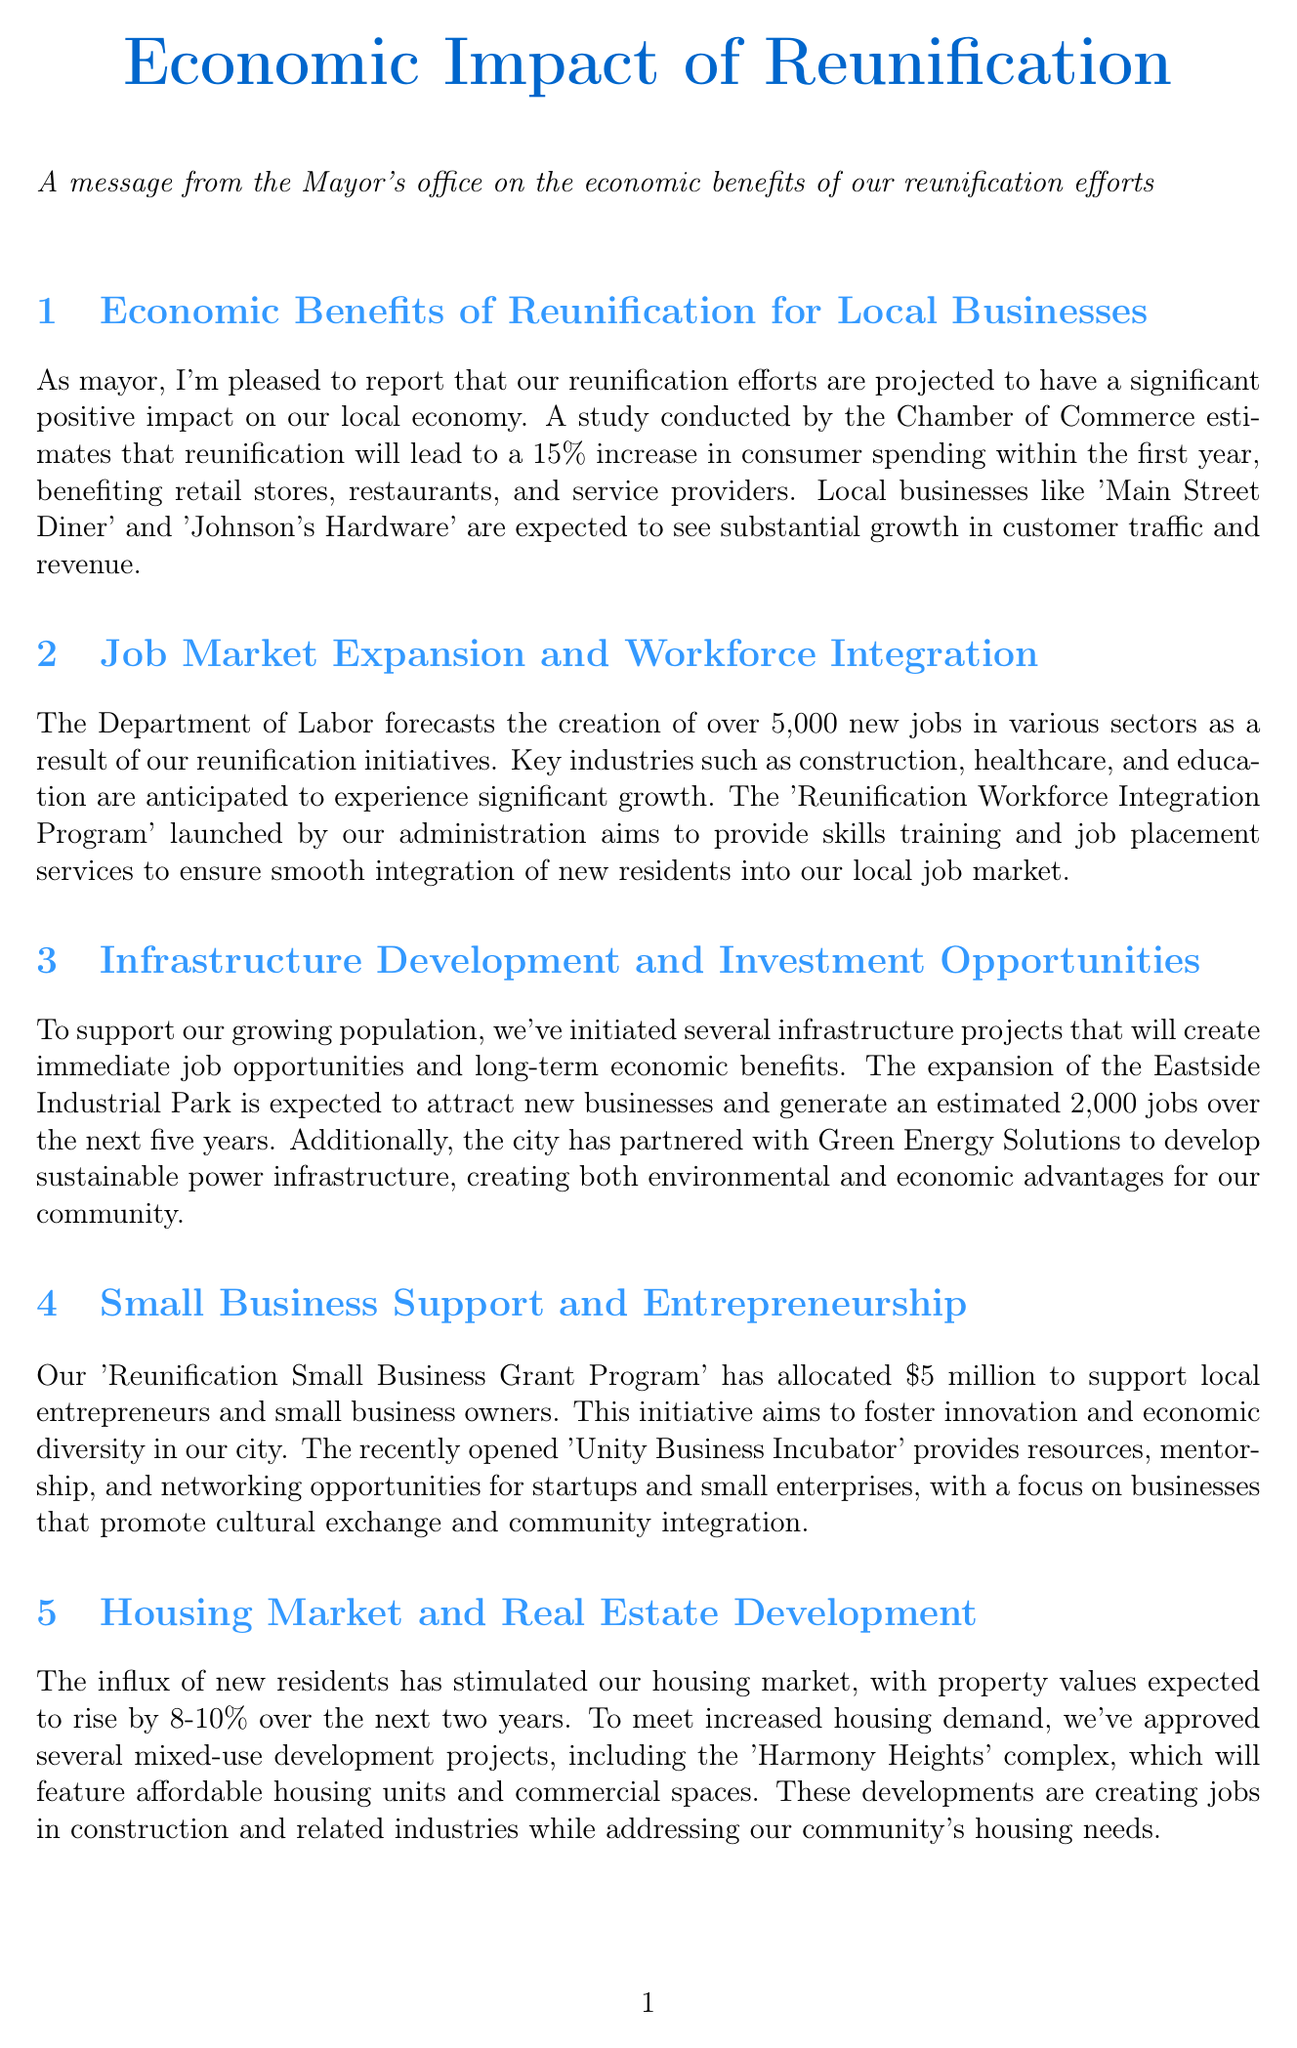What is the projected increase in consumer spending? The document states that reunification will lead to a 15% increase in consumer spending.
Answer: 15% How many new jobs are expected to be created? The document mentions that over 5,000 new jobs are forecasted to be created due to reunification initiatives.
Answer: 5,000 What is the allocated amount for the Small Business Grant Program? The document indicates that the 'Reunification Small Business Grant Program' has allocated $5 million to support local entrepreneurs.
Answer: $5 million What is the expected rise in property values? The document states that property values are expected to rise by 8-10% over the next two years.
Answer: 8-10% What festival is expected to generate economic activity? The document mentions the annual 'Unity Festival' as a major draw for visitors that will generate local economic activity.
Answer: Unity Festival What is the focus of the 'Unity Business Incubator'? The document describes that the 'Unity Business Incubator' focuses on businesses that promote cultural exchange and community integration.
Answer: Cultural exchange and community integration How many jobs will the Eastside Industrial Park expansion generate? The document estimates that the expansion of the Eastside Industrial Park will generate approximately 2,000 jobs over the next five years.
Answer: 2,000 What percentage increase in tourism is anticipated? The document states that a 20% increase in tourism is anticipated as a result of reunification efforts.
Answer: 20% 